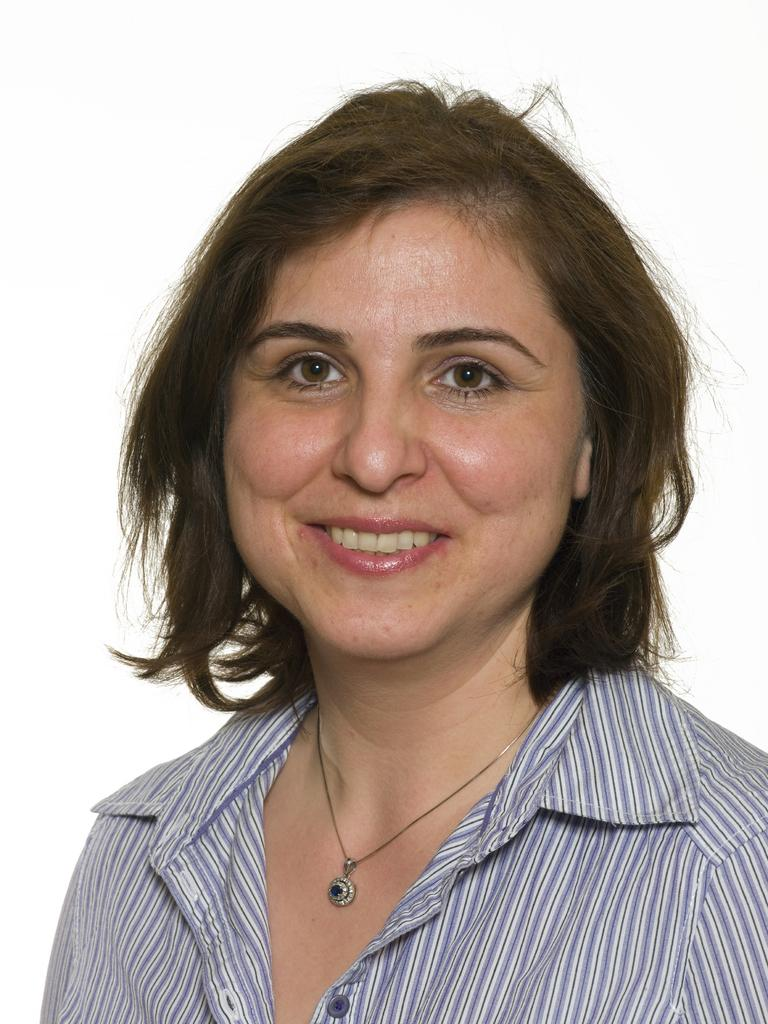Who is the main subject in the image? There is a woman in the image. What is the woman's facial expression? The woman is smiling. In which direction is the woman looking? The woman is looking forward. What color is the background of the image? The background of the image is white. What type of shoes is the woman wearing in the image? There is no information about shoes in the image, as the focus is on the woman's facial expression and the background. 